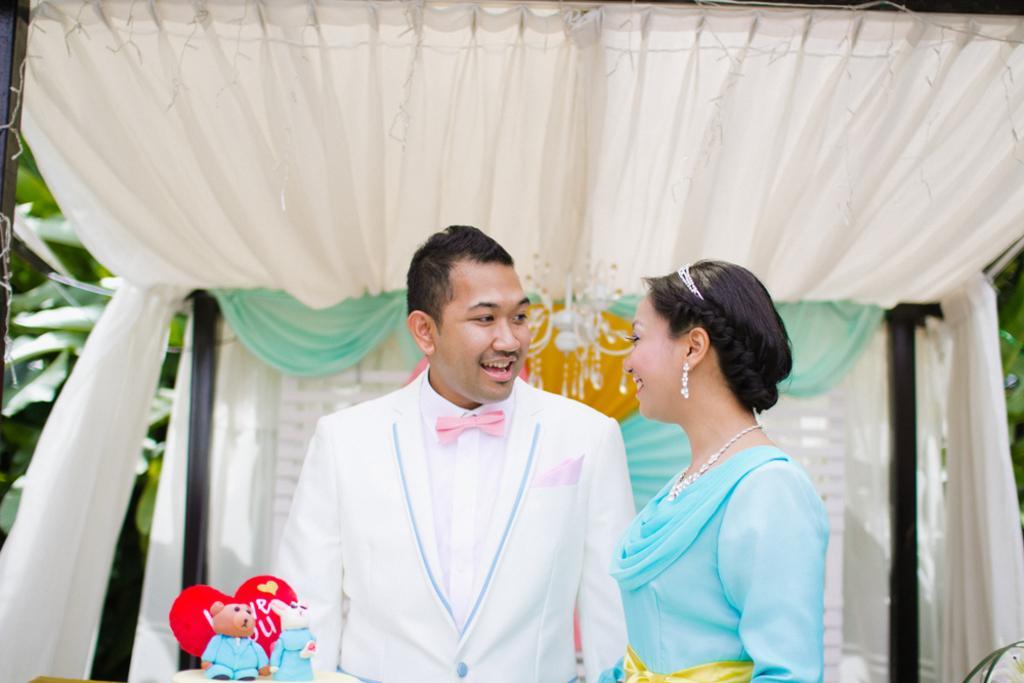In one or two sentences, can you explain what this image depicts? In this picture there are two people standing and smiling and we can see toys, curtains and decorative items. In the background of the image we can see leaves. 